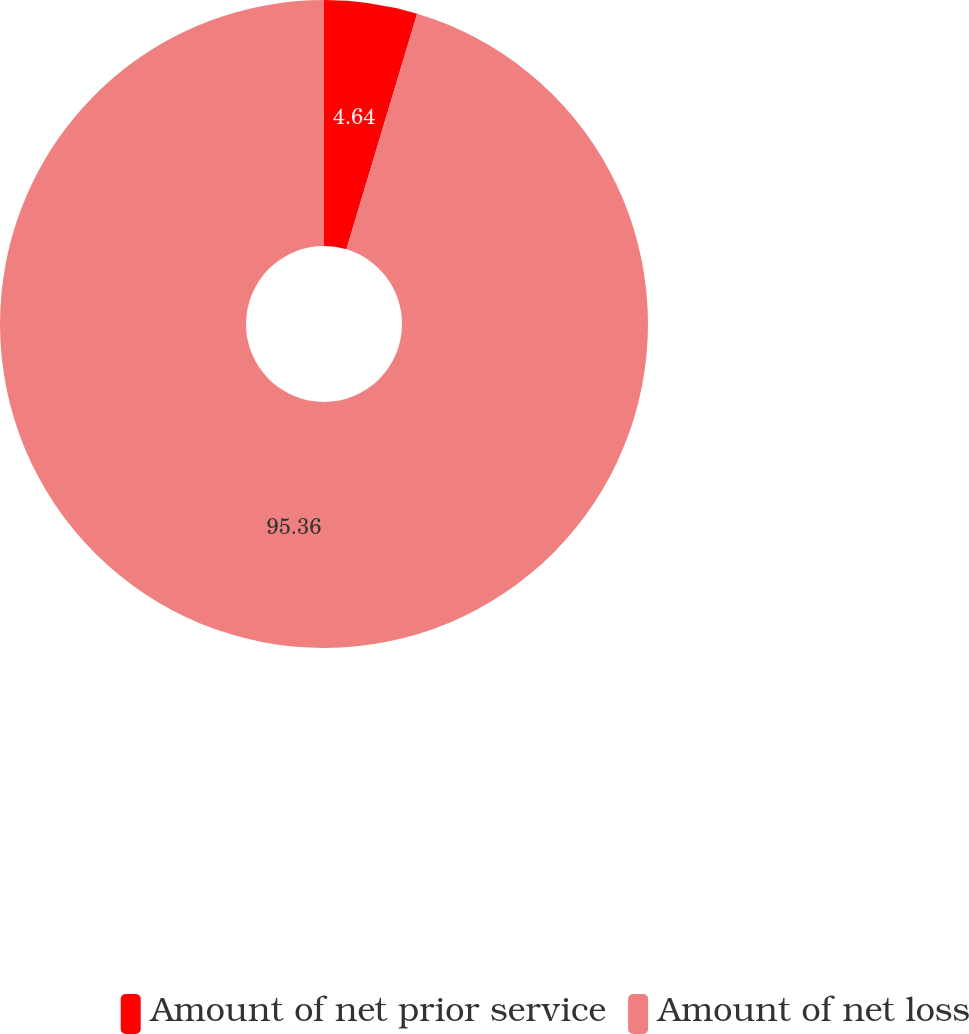Convert chart. <chart><loc_0><loc_0><loc_500><loc_500><pie_chart><fcel>Amount of net prior service<fcel>Amount of net loss<nl><fcel>4.64%<fcel>95.36%<nl></chart> 